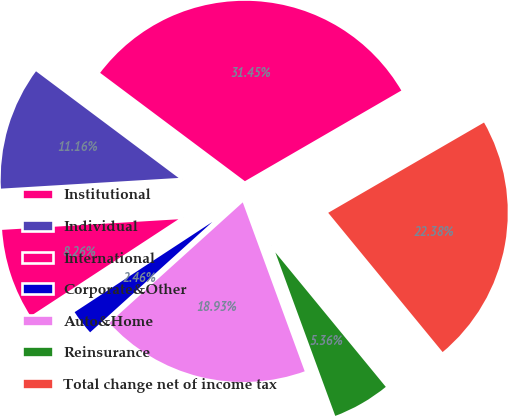Convert chart. <chart><loc_0><loc_0><loc_500><loc_500><pie_chart><fcel>Institutional<fcel>Individual<fcel>International<fcel>Corporate&Other<fcel>Auto&Home<fcel>Reinsurance<fcel>Total change net of income tax<nl><fcel>31.45%<fcel>11.16%<fcel>8.26%<fcel>2.46%<fcel>18.93%<fcel>5.36%<fcel>22.38%<nl></chart> 